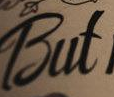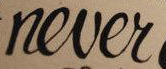What text appears in these images from left to right, separated by a semicolon? But; never 